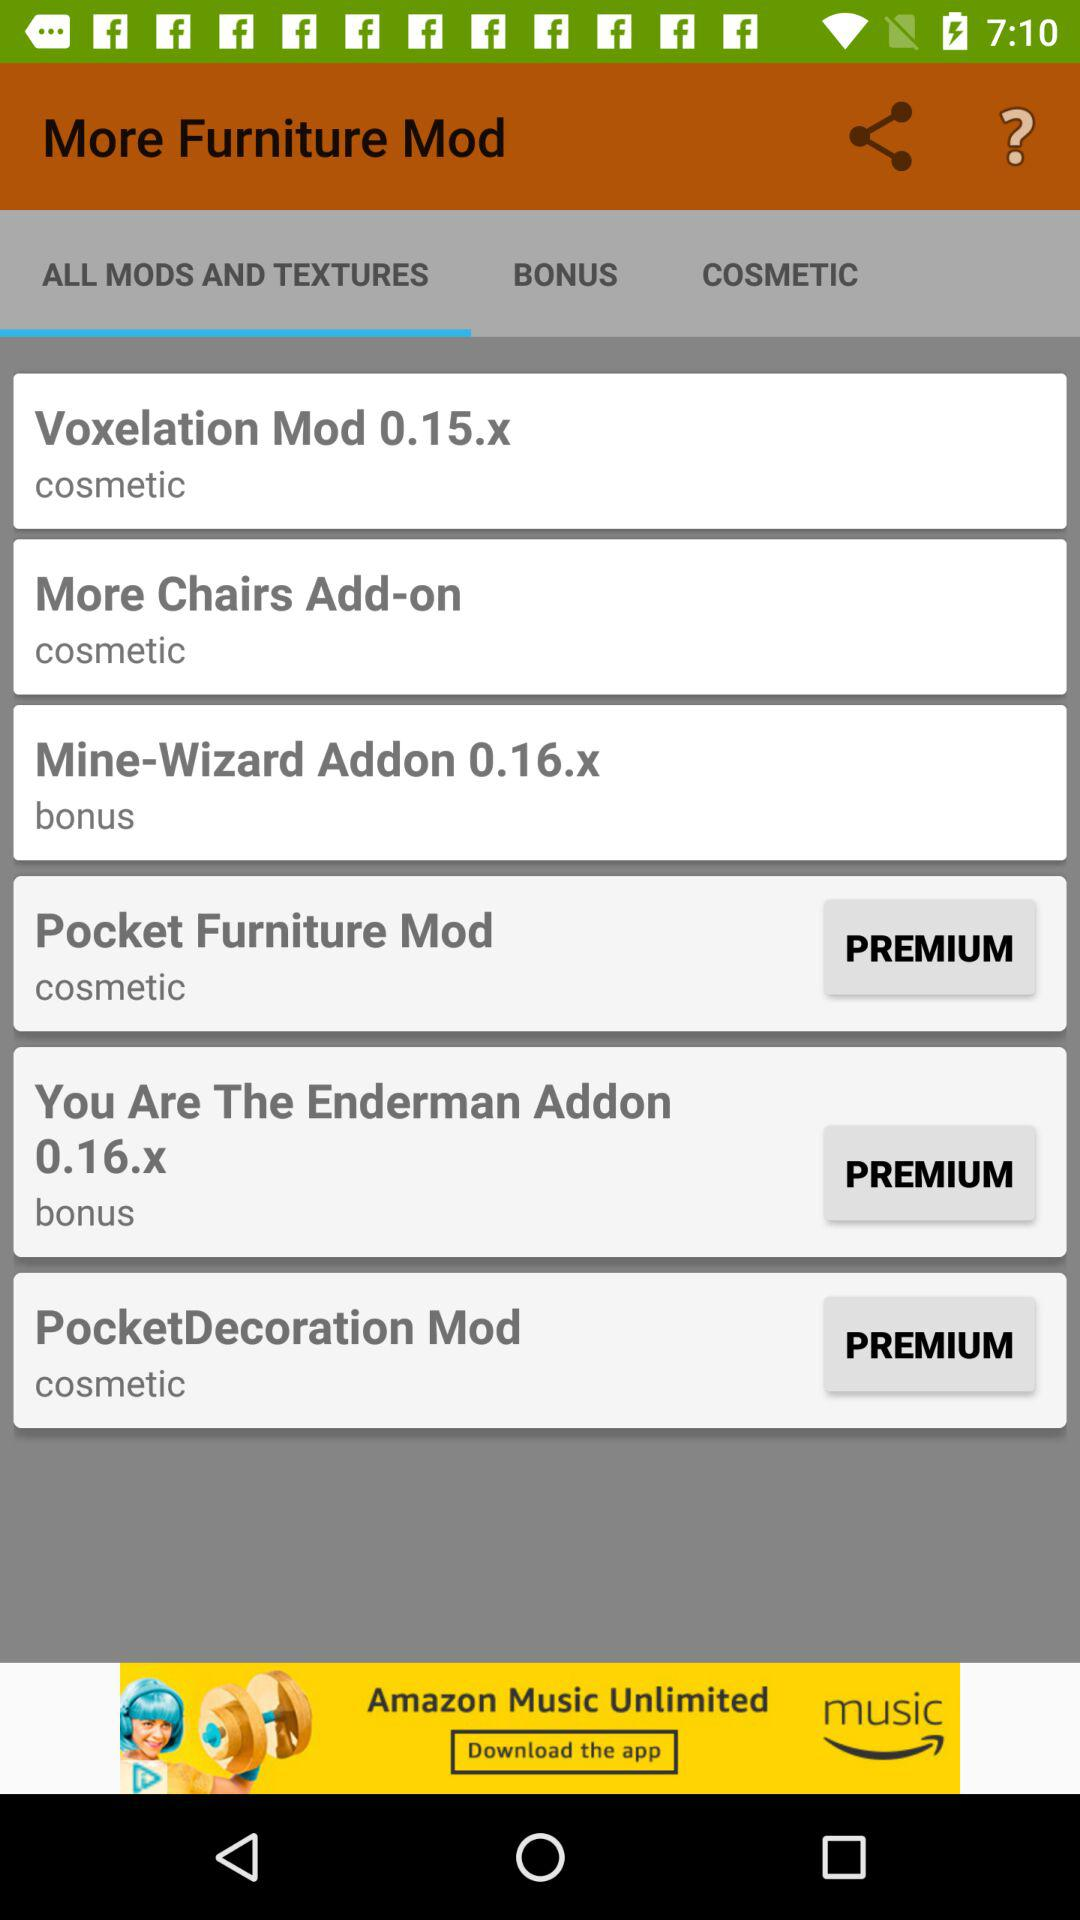Which furniture mod has a premium option? The furniture mods are "Pocket Furniture Mod", "You Are The Enderman Addon 0.16.x" and "PocketDecoration Mod". 